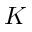<formula> <loc_0><loc_0><loc_500><loc_500>K</formula> 